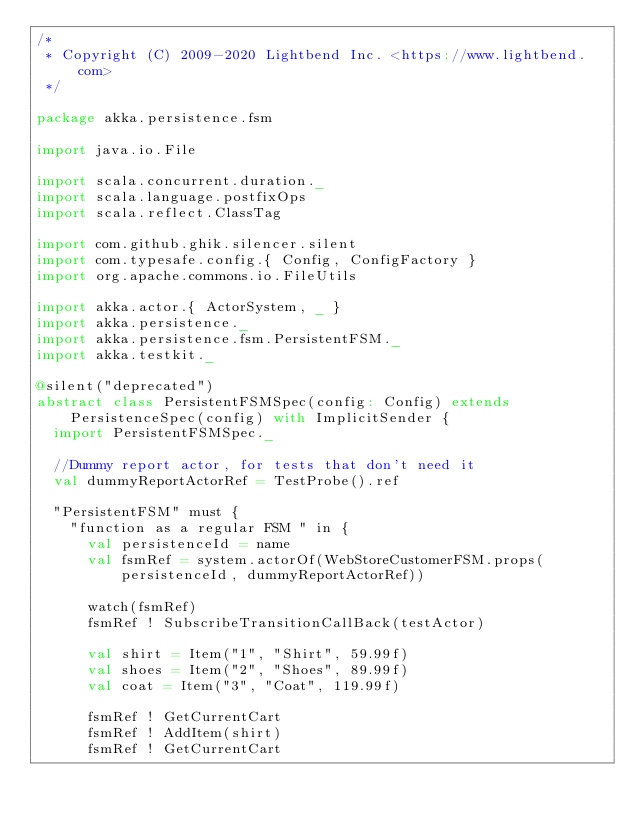<code> <loc_0><loc_0><loc_500><loc_500><_Scala_>/*
 * Copyright (C) 2009-2020 Lightbend Inc. <https://www.lightbend.com>
 */

package akka.persistence.fsm

import java.io.File

import scala.concurrent.duration._
import scala.language.postfixOps
import scala.reflect.ClassTag

import com.github.ghik.silencer.silent
import com.typesafe.config.{ Config, ConfigFactory }
import org.apache.commons.io.FileUtils

import akka.actor.{ ActorSystem, _ }
import akka.persistence._
import akka.persistence.fsm.PersistentFSM._
import akka.testkit._

@silent("deprecated")
abstract class PersistentFSMSpec(config: Config) extends PersistenceSpec(config) with ImplicitSender {
  import PersistentFSMSpec._

  //Dummy report actor, for tests that don't need it
  val dummyReportActorRef = TestProbe().ref

  "PersistentFSM" must {
    "function as a regular FSM " in {
      val persistenceId = name
      val fsmRef = system.actorOf(WebStoreCustomerFSM.props(persistenceId, dummyReportActorRef))

      watch(fsmRef)
      fsmRef ! SubscribeTransitionCallBack(testActor)

      val shirt = Item("1", "Shirt", 59.99f)
      val shoes = Item("2", "Shoes", 89.99f)
      val coat = Item("3", "Coat", 119.99f)

      fsmRef ! GetCurrentCart
      fsmRef ! AddItem(shirt)
      fsmRef ! GetCurrentCart</code> 